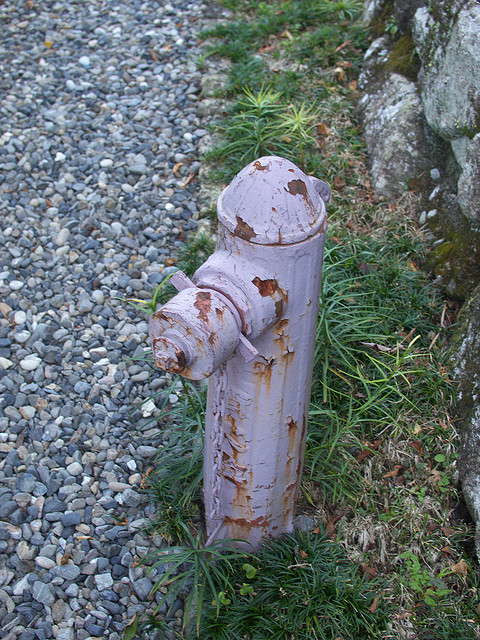Is there water in the image? No, there is no visible water in the image. 